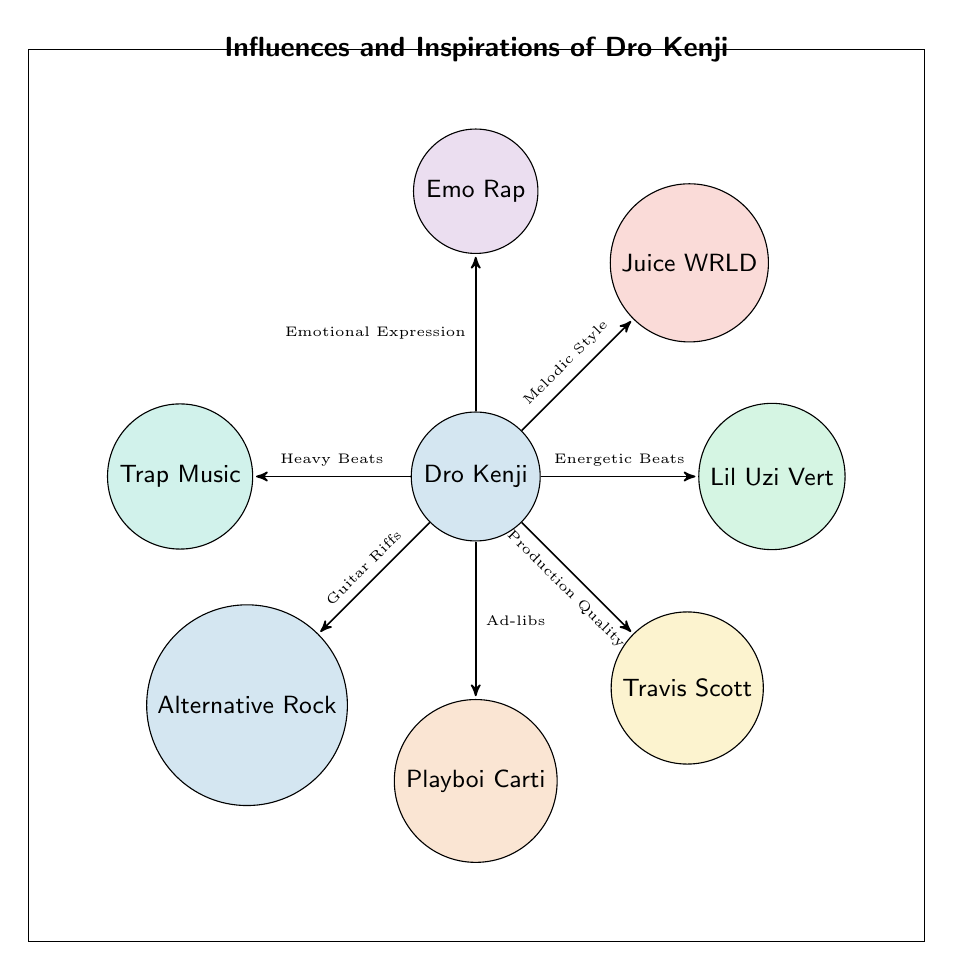What is the primary influence with the highest impact on Dro Kenji's music? The diagram shows the influences on Dro Kenji, with links indicating their relative impact. Emo Rap is linked to Dro Kenji with the highest value of 9, indicating its primary influence.
Answer: Emo Rap Which influence is associated with energetic beats? The diagram indicates that Lil Uzi Vert has a link to Dro Kenji with the impact labeled as "Energetic Beats." This information is derived from the specific link description.
Answer: Lil Uzi Vert How many total influences are shown in the diagram? The diagram contains 7 nodes that represent different influences on Dro Kenji's music. By counting the nodes listed, we see there are 7 influences in total.
Answer: 7 What impact does Juice WRLD have on Dro Kenji's music? The diagram specifies that Juice WRLD has an impact on Dro Kenji described as "Melodic Style, Emotional Lyrics." The associated value is 8, showing its significant influence.
Answer: Melodic Style, Emotional Lyrics Which influence contributes guitar riffs to Dro Kenji's style? Analyzing the links in the diagram, Alternative Rock is shown to be connected to Dro Kenji with the impact described as "Guitar Riffs." This directly answers the query.
Answer: Alternative Rock What is the value assigned to the influence of Trap Music? The link from Trap Music to Dro Kenji in the diagram is assigned a value of 7. This can be found by checking the specific numerical link between the two nodes.
Answer: 7 Which influence is least represented in the diagram? By examining the impact values listed, Alternative Rock has the lowest value of 4 compared to all other influences, making it the least represented in terms of influence on Dro Kenji.
Answer: Alternative Rock How does Playboi Carti influence Dro Kenji? According to the diagram, Playboi Carti is connected to Dro Kenji with the impact of "Ad-libs, Experimental Style." This is stated directly on the link from Playboi Carti to Dro Kenji.
Answer: Ad-libs, Experimental Style 